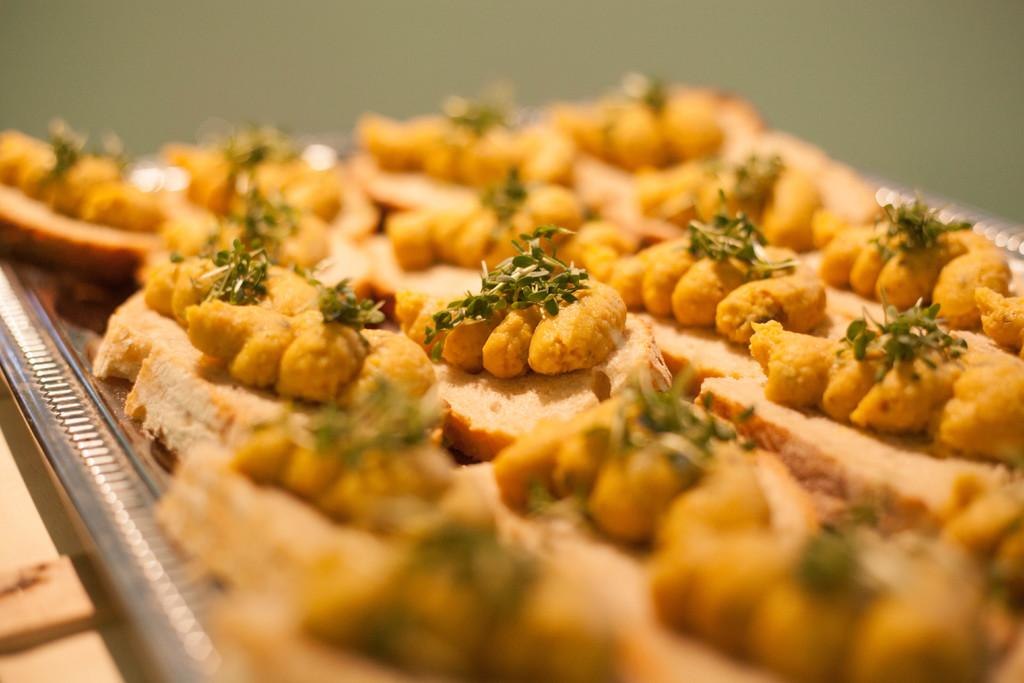What object is present in the image that can hold items? There is a tray in the image that can hold items. What type of items can be seen on the tray? The tray contains food items. Can you describe the background of the image? The background of the image is blurred. Is there a snail crawling on the stove in the image? There is no stove or snail present in the image. 